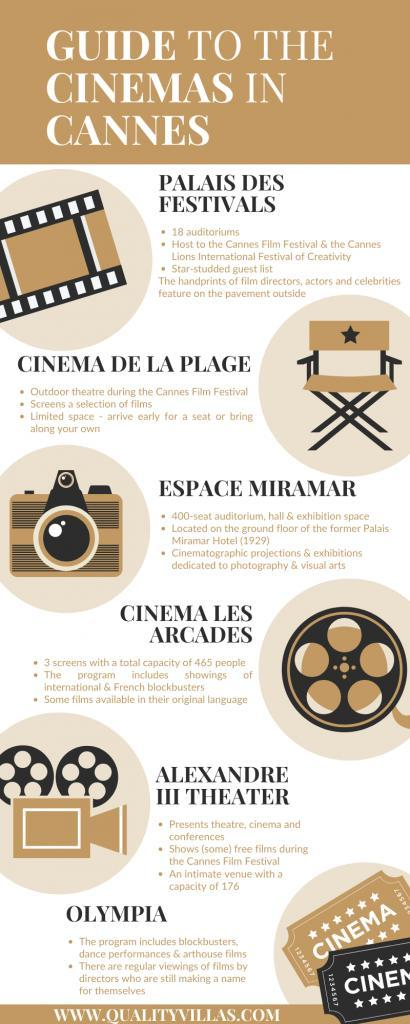Which theatre has regular viewings of films by new directors who are making a name for themselves?
Answer the question with a short phrase. Olympia When are free films shown in Alexandre III theatre? Cannes Film festival How much more is the capacity of Cinema Les Arcades when compared to that of Alexandre III theatre? 289 What are the main facilities in Espace Miramar? 400-seat auditorium, hall & exhibition space How many cinemas centers are mentioned in this guide? 6 How many bullet points are there under Olympia? 2 Which two festivals where hosted at Palais des Festivals? Cannes Film festival & the Cannes Lions International festival of Creativity What image represents Cinema de la Plage - camera, reel or seat? seat How many individuals can the screens at Cinema Les Arcades hold? 465 